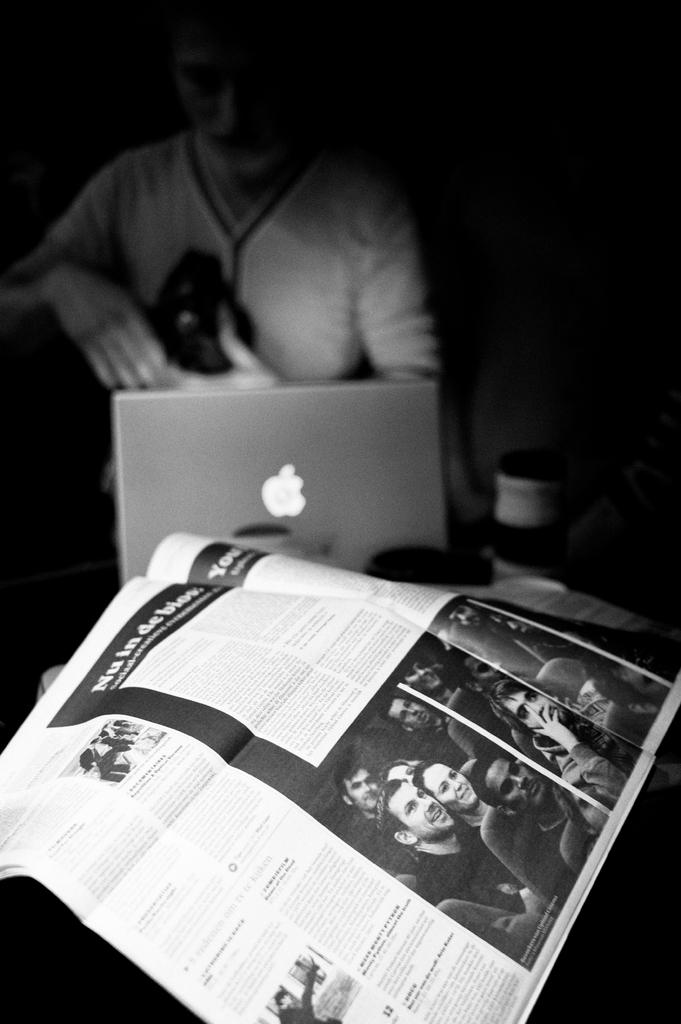What is the color scheme of the image? The image is black and white. What is the person in the image holding? There is a person holding an object in the image. What type of electronic device is visible in the image? There is a laptop in the image. the image. What type of reading material is present in the image? There is a newspaper in the image. Can you describe any other objects present in the image? There are other objects present in the image, but their specific details are not mentioned in the provided facts. How many snakes are slithering on the laptop in the image? There are no snakes present in the image; it features a person holding an object, a laptop, and a newspaper. What type of design is featured on the toys in the image? There are no toys present in the image, so it is not possible to describe their design. 